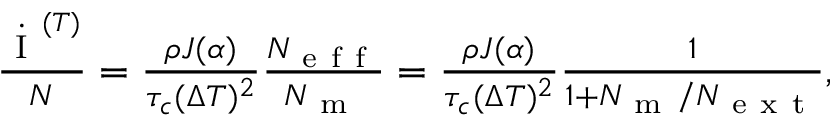Convert formula to latex. <formula><loc_0><loc_0><loc_500><loc_500>\begin{array} { r } { \frac { \dot { I } ^ { ( T ) } } { N } = \frac { \rho J ( \alpha ) } { \tau _ { c } ( \Delta T ) ^ { 2 } } \frac { N _ { e f f } } { N _ { m } } = \frac { \rho J ( \alpha ) } { \tau _ { c } ( \Delta T ) ^ { 2 } } \frac { 1 } { 1 + N _ { m } / N _ { e x t } } , } \end{array}</formula> 